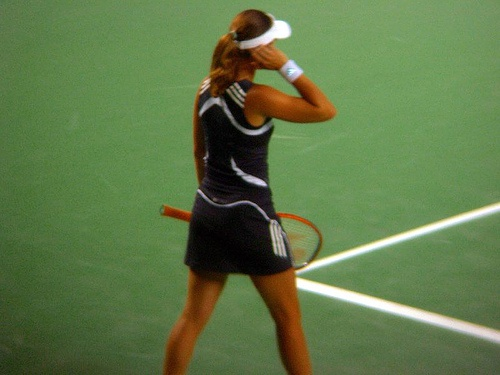Describe the objects in this image and their specific colors. I can see people in green, black, maroon, brown, and olive tones and tennis racket in green, olive, and brown tones in this image. 